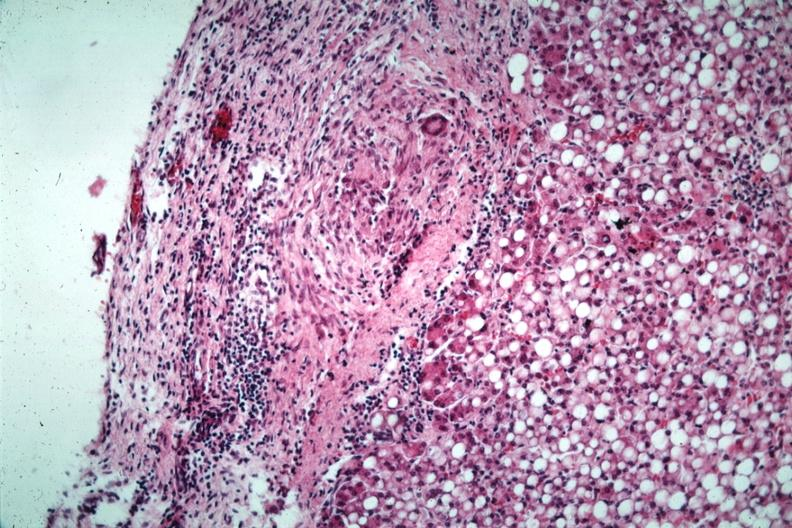s peritoneum present?
Answer the question using a single word or phrase. Yes 